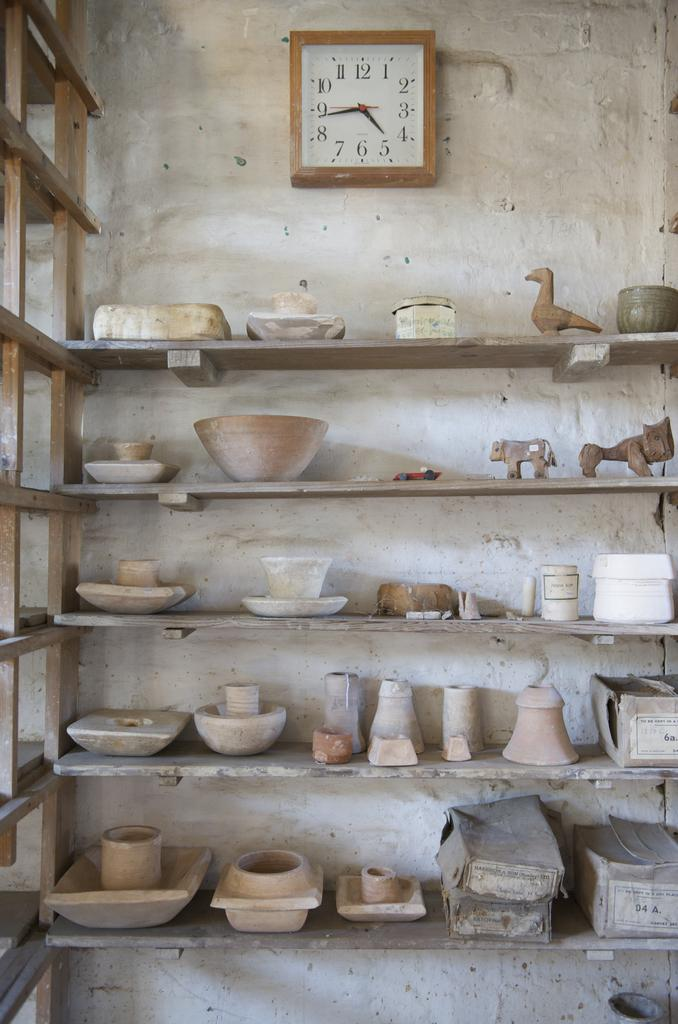<image>
Summarize the visual content of the image. A wood shelf holding different size ceramic bowls and jars sits underneath a clock reading 4:48. 